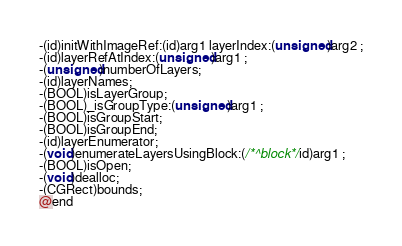<code> <loc_0><loc_0><loc_500><loc_500><_C_>-(id)initWithImageRef:(id)arg1 layerIndex:(unsigned)arg2 ;
-(id)layerRefAtIndex:(unsigned)arg1 ;
-(unsigned)numberOfLayers;
-(id)layerNames;
-(BOOL)isLayerGroup;
-(BOOL)_isGroupType:(unsigned)arg1 ;
-(BOOL)isGroupStart;
-(BOOL)isGroupEnd;
-(id)layerEnumerator;
-(void)enumerateLayersUsingBlock:(/*^block*/id)arg1 ;
-(BOOL)isOpen;
-(void)dealloc;
-(CGRect)bounds;
@end

</code> 